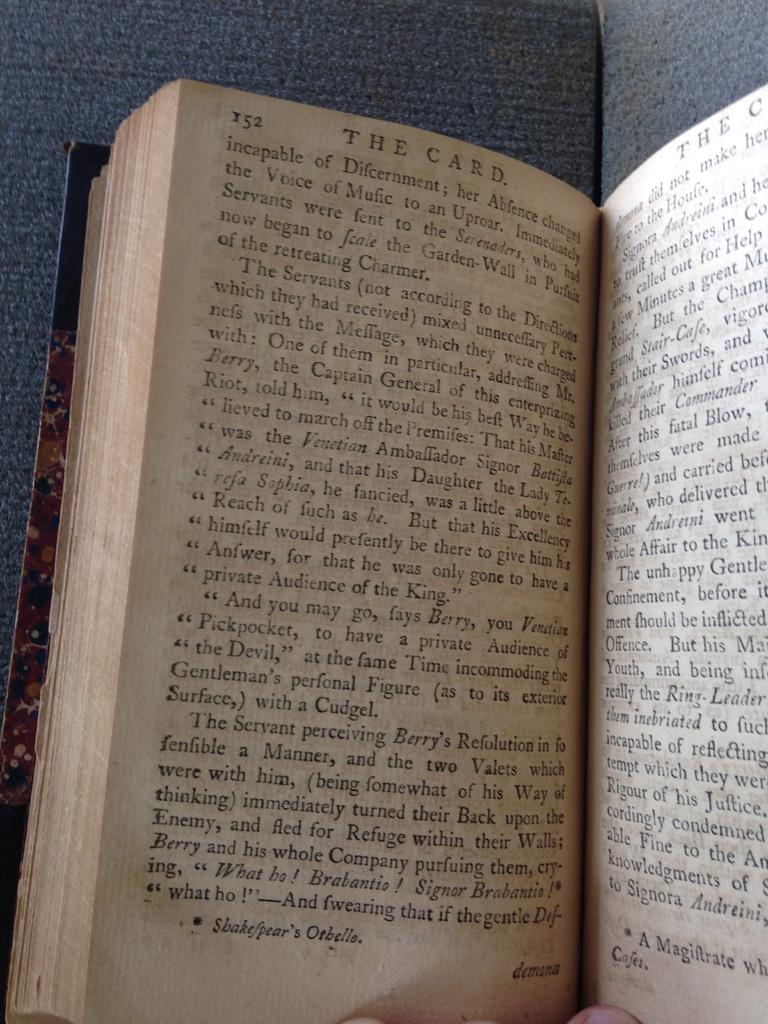What is the title shown on page 152?
Ensure brevity in your answer.  The card. What is the page number?
Your response must be concise. 152. 